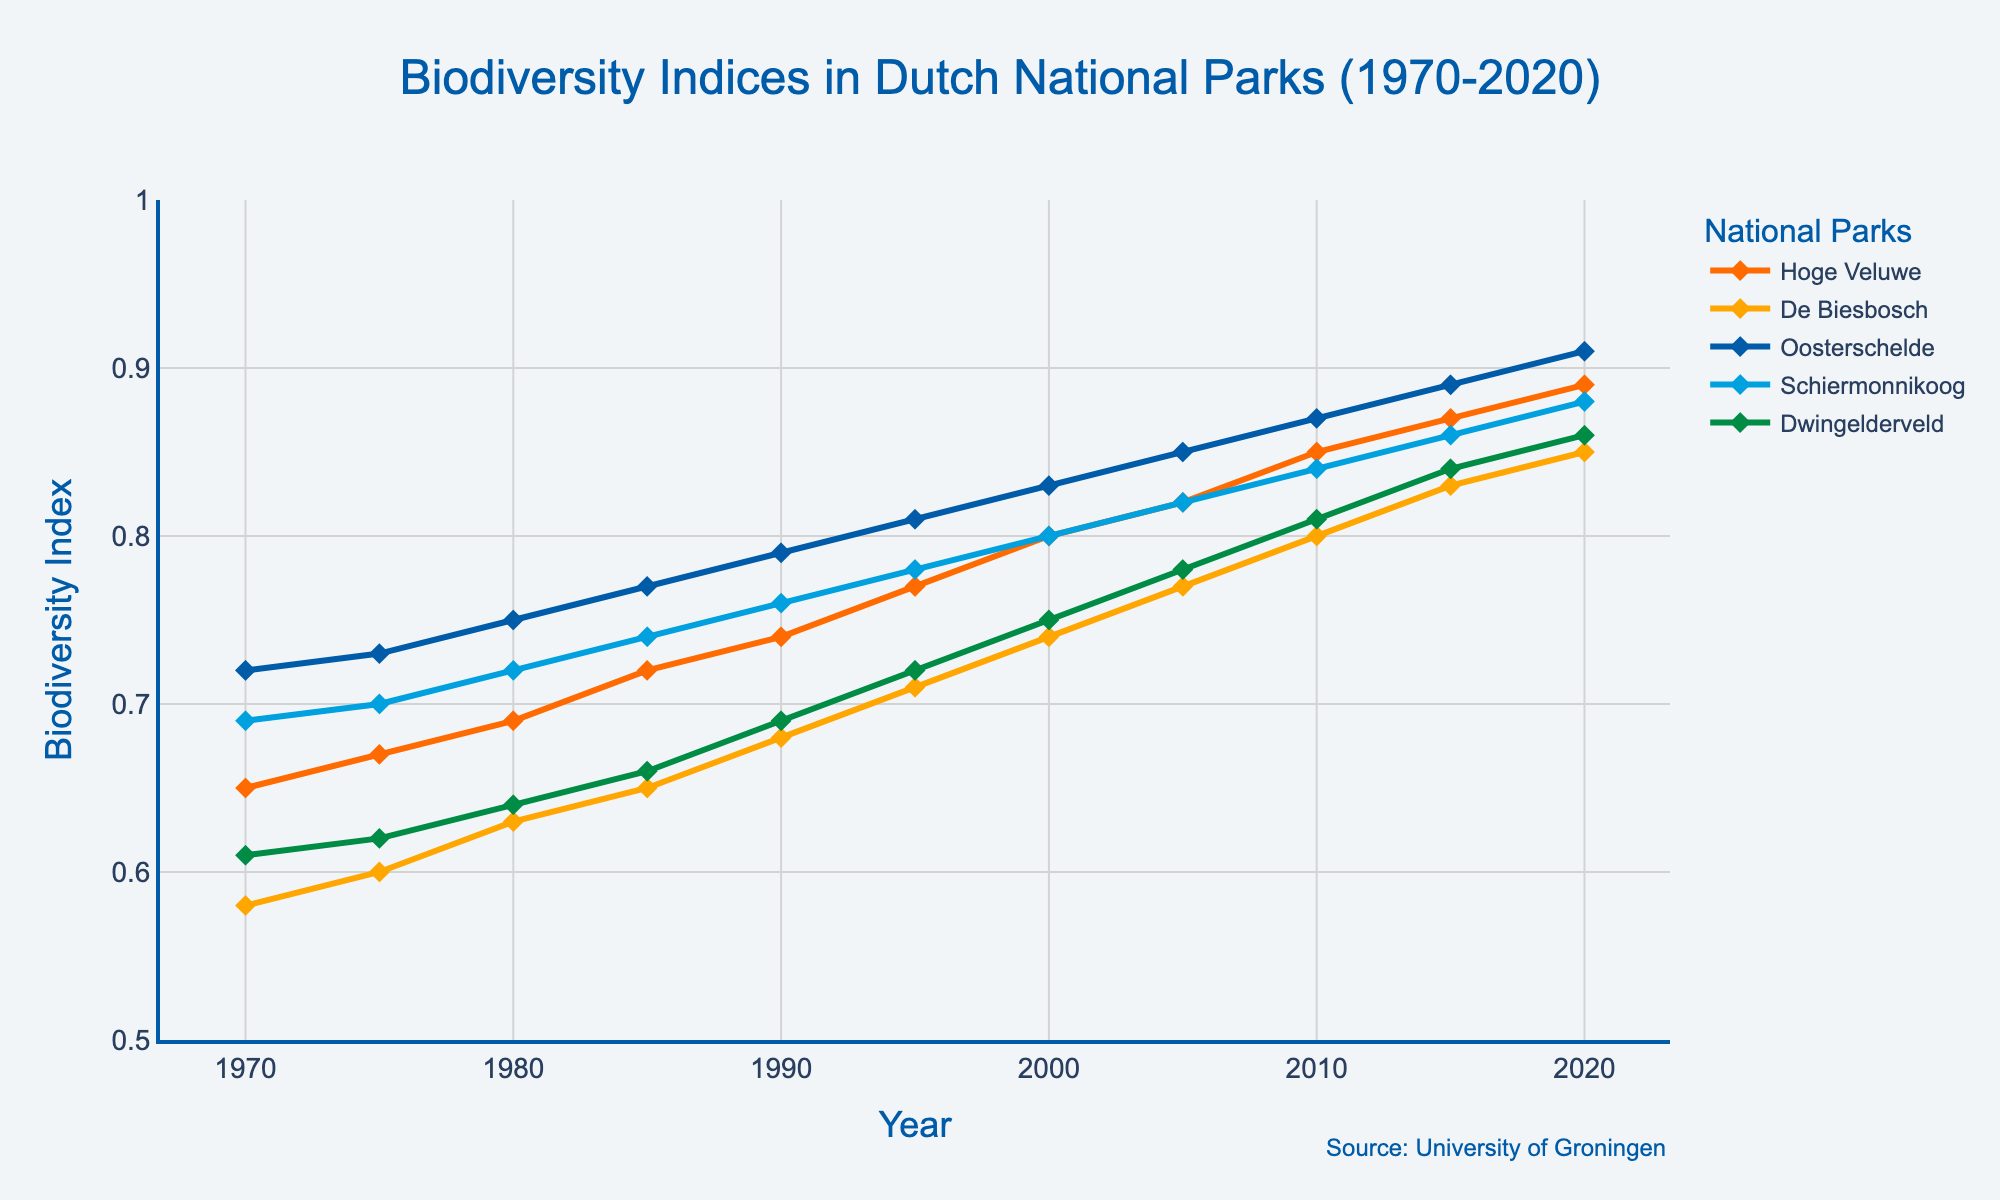What trend do you observe in the biodiversity index of Hoge Veluwe from 1970 to 2020? The biodiversity index of Hoge Veluwe shows a consistent upward trend from 0.65 in 1970 to 0.89 in 2020. Each data point is progressively higher, indicating a steady increase over the years.
Answer: Increasing trend Which national park had the highest biodiversity index in 2020? In 2020, the figure shows that Oosterschelde had the highest biodiversity index, which is 0.91. The other national parks had indices lower than this value.
Answer: Oosterschelde What is the difference in the biodiversity index between De Biesbosch and Schiermonnikoog in 1990? In 1990, the biodiversity index of De Biesbosch is 0.68 and Schiermonnikoog is 0.76. The difference can be calculated as 0.76 - 0.68 = 0.08.
Answer: 0.08 How has the biodiversity index of Schiermonnikoog changed between 1985 and 2000? In 1985, the biodiversity index of Schiermonnikoog is 0.74 and in 2000 it is 0.80. The change is 0.80 - 0.74 = 0.06, indicating an increase.
Answer: Increased by 0.06 Which two parks had the closest biodiversity indices in 2015? In 2015, De Biesbosch and Schiermonnikoog had biodiversity indices of 0.83 and 0.86, respectively, making the difference 0.86 - 0.83 = 0.03, which is the smallest difference between any pairs of parks.
Answer: De Biesbosch and Schiermonnikoog Did all national parks show an increasing trend in biodiversity indices from 1970 to 2020? Yes, all national parks (Hoge Veluwe, De Biesbosch, Oosterschelde, Schiermonnikoog, and Dwingelderveld) show an increasing trend in their biodiversity indices from 1970 to 2020. Each line graph moves upward over time without any significant declines.
Answer: Yes What is the average biodiversity index for Dwingelderveld across all the years provided? The biodiversity indices for Dwingelderveld from 1970 to 2020 are: 0.61, 0.62, 0.64, 0.66, 0.69, 0.72, 0.75, 0.78, 0.81, 0.84, and 0.86. Summing these gives 0.61 + 0.62 + 0.64 + 0.66 + 0.69 + 0.72 + 0.75 + 0.78 + 0.81 + 0.84 + 0.86 = 8.18. The average is 8.18 / 11 = 0.74.
Answer: 0.74 Between which consecutive years did Oosterschelde experience the highest increase in biodiversity index? The changes in biodiversity index for Oosterschelde across the intervals are:
1970-1975: 0.73 - 0.72 = 0.01, 1975-1980: 0.75 - 0.73 = 0.02, 1980-1985: 0.77 - 0.75 = 0.02, 1985-1990: 0.79 - 0.77 = 0.02, 1990-1995: 0.81 - 0.79 = 0.02, 1995-2000: 0.83 - 0.81 = 0.02, 2000-2005: 0.85 - 0.83 = 0.02, 2005-2010: 0.87 - 0.85 = 0.02, 2010-2015: 0.89 - 0.87 = 0.02, 2015-2020: 0.91 - 0.89 = 0.02. 
All increases are the same at 0.02, so no single period has a uniquely highest increase.
Answer: 0.02 in all intervals If we observe the color of the line for Dwingelderveld, what color is it? The color of the line for Dwingelderveld is green, as indicated by the line in the figure.
Answer: Green 